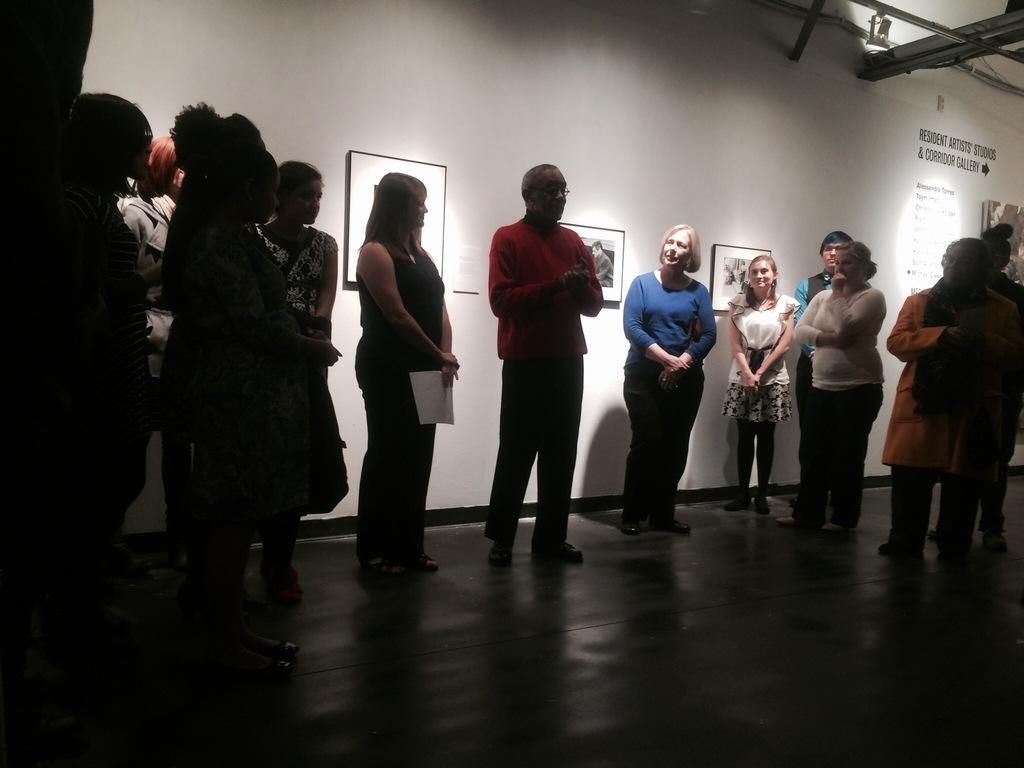Please provide a concise description of this image. This picture seems to be clicked inside the hall. In the center we can see the group of people standing on the ground. In the background we can see the wall, picture frames hanging on the wall and we can see the text and the metal rods and some other objects. 